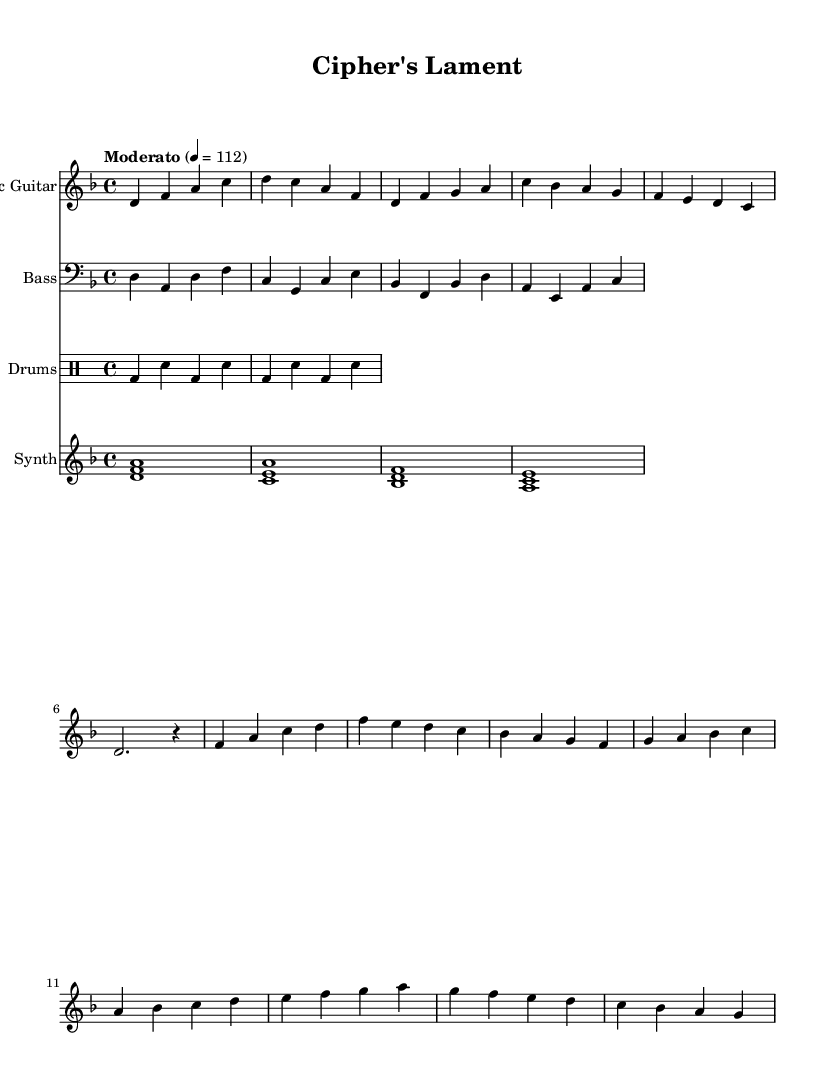What is the key signature of this music? The key signature is D minor, which has one flat (B flat). The key signature is specified at the beginning of the score and affects the notes throughout the piece.
Answer: D minor What is the time signature of this music? The time signature is 4/4, which indicates there are four beats in each measure and the quarter note gets one beat. The time signature is indicated at the beginning of the score right after the key signature.
Answer: 4/4 What is the tempo marking for this piece? The tempo marking is "Moderato," and the beats per minute (BPM) are set at 112. This information is found at the beginning of the score and guides the performance speed.
Answer: Moderato 4 = 112 How many measures are in the chorus section? The chorus section consists of four measures. By visually counting the measures in the section labeled as the chorus, we see four distinct measures.
Answer: 4 Which instrument plays the main melody in the introduction? The electric guitar plays the main melody in the introduction, as seen from its notation and the fact that it starts the piece. The introduction is displayed prominently under the electric guitar staff.
Answer: Electric Guitar What chord does the synth play in the first measure? The synth plays a D minor chord in the first measure, represented by the notes D, F, and A stacked vertically. This is visually confirmed by looking at the first measure of the synth staff.
Answer: D minor What type of rhythmic pattern is used in the drum section? The drum section follows a simple alternating pattern of bass drum and snare drum, as indicated by the notation in the drummode section. This pattern consists of bass drum hits on beats 1 and 3, and snare hits on beats 2 and 4.
Answer: Alternating bass and snare 